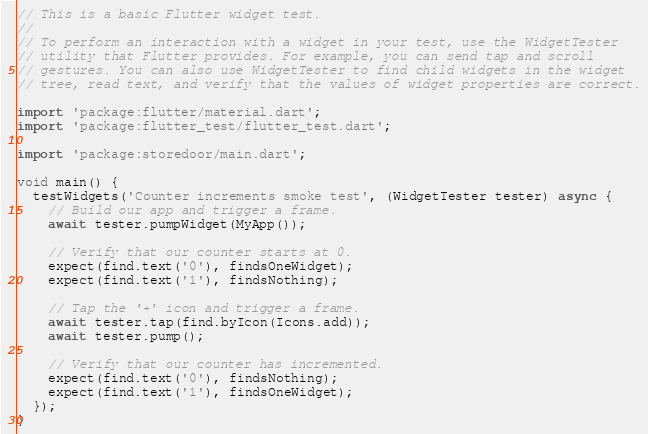Convert code to text. <code><loc_0><loc_0><loc_500><loc_500><_Dart_>// This is a basic Flutter widget test.
//
// To perform an interaction with a widget in your test, use the WidgetTester
// utility that Flutter provides. For example, you can send tap and scroll
// gestures. You can also use WidgetTester to find child widgets in the widget
// tree, read text, and verify that the values of widget properties are correct.

import 'package:flutter/material.dart';
import 'package:flutter_test/flutter_test.dart';

import 'package:storedoor/main.dart';

void main() {
  testWidgets('Counter increments smoke test', (WidgetTester tester) async {
    // Build our app and trigger a frame.
    await tester.pumpWidget(MyApp());

    // Verify that our counter starts at 0.
    expect(find.text('0'), findsOneWidget);
    expect(find.text('1'), findsNothing);

    // Tap the '+' icon and trigger a frame.
    await tester.tap(find.byIcon(Icons.add));
    await tester.pump();

    // Verify that our counter has incremented.
    expect(find.text('0'), findsNothing);
    expect(find.text('1'), findsOneWidget);
  });
}
</code> 